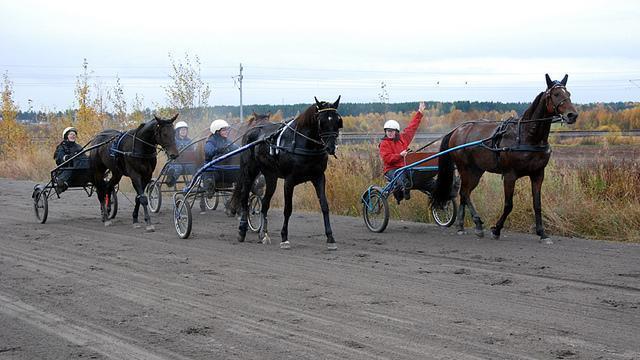How many horses are there?
Give a very brief answer. 3. How many wheels do these carts have?
Give a very brief answer. 2. How many horses can be seen?
Give a very brief answer. 3. 